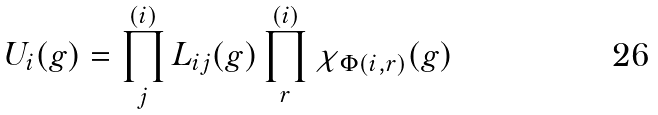Convert formula to latex. <formula><loc_0><loc_0><loc_500><loc_500>U _ { i } ( g ) = \prod _ { j } ^ { ( i ) } L _ { i j } ( g ) \prod _ { r } ^ { ( i ) } \chi _ { \Phi ( i , r ) } ( g )</formula> 